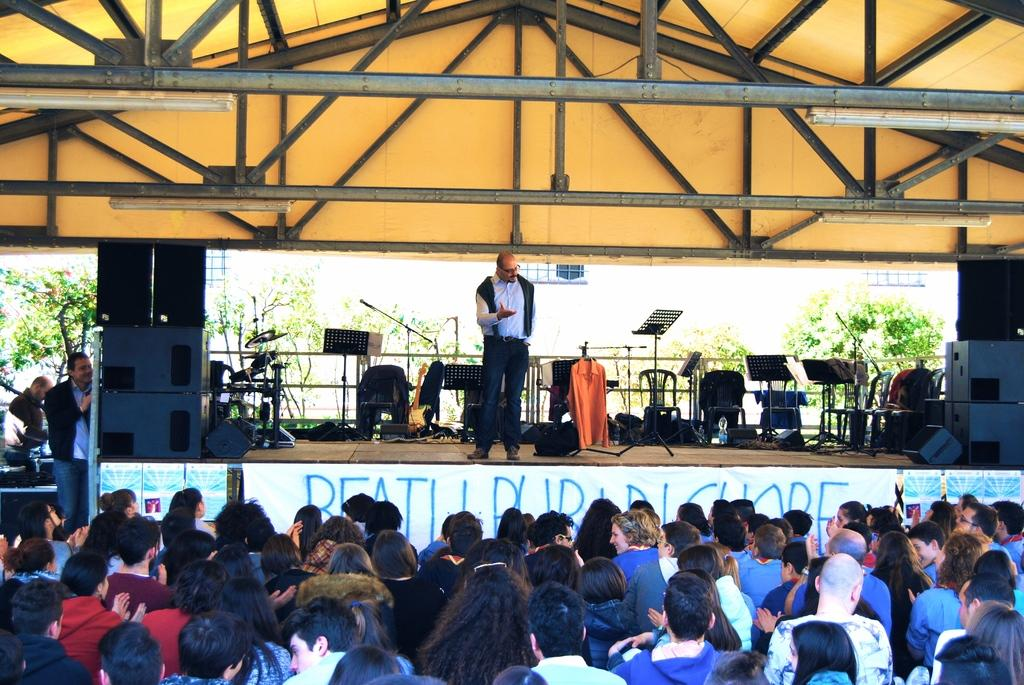Who or what can be seen in the image? There are people in the image. What type of natural elements are present in the image? There are trees in the image. What musical instruments are visible in the image? Musical drums are present in the image. What equipment is used for amplifying sound in the image? Mics are visible in the image. What type of seating is available in the image? Chairs are in the image. Where is a person located in the image? There is a person standing on stage in the image. What type of leather is used to make the grass in the image? There is no leather or grass present in the image. What type of pleasure can be derived from the performance in the image? The image does not convey any specific emotions or pleasures; it simply shows people, trees, musical instruments, mics, chairs, and a person on stage. 